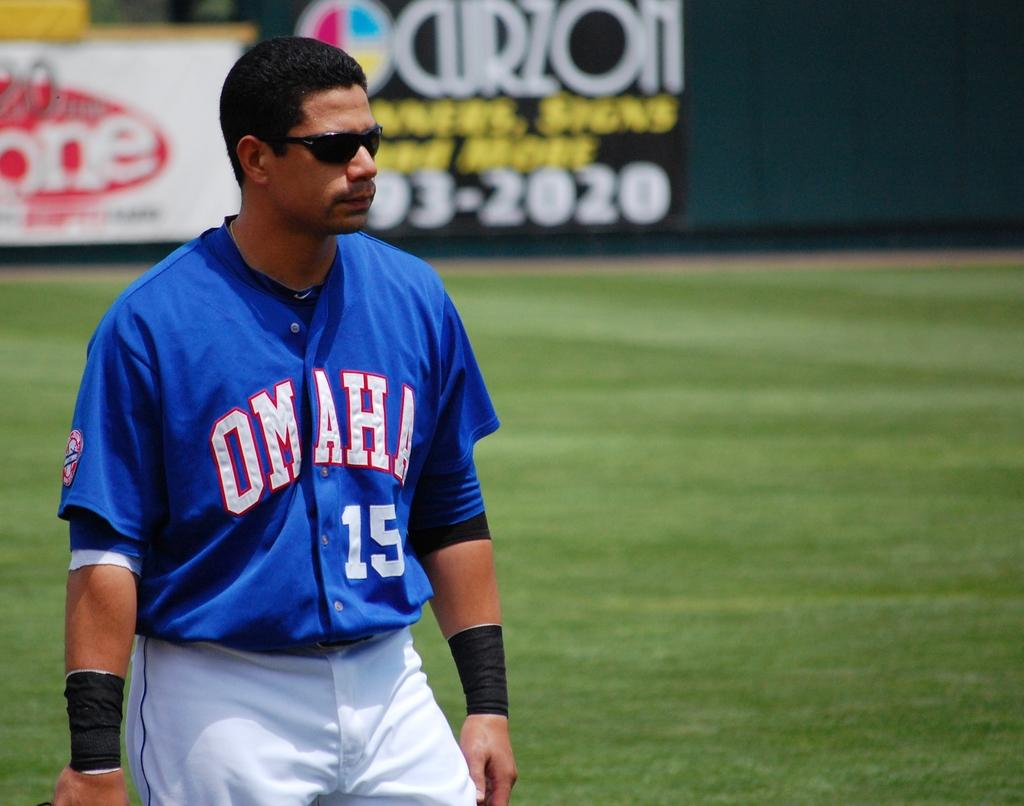<image>
Create a compact narrative representing the image presented. player number 15 for Omaha stands on the field 